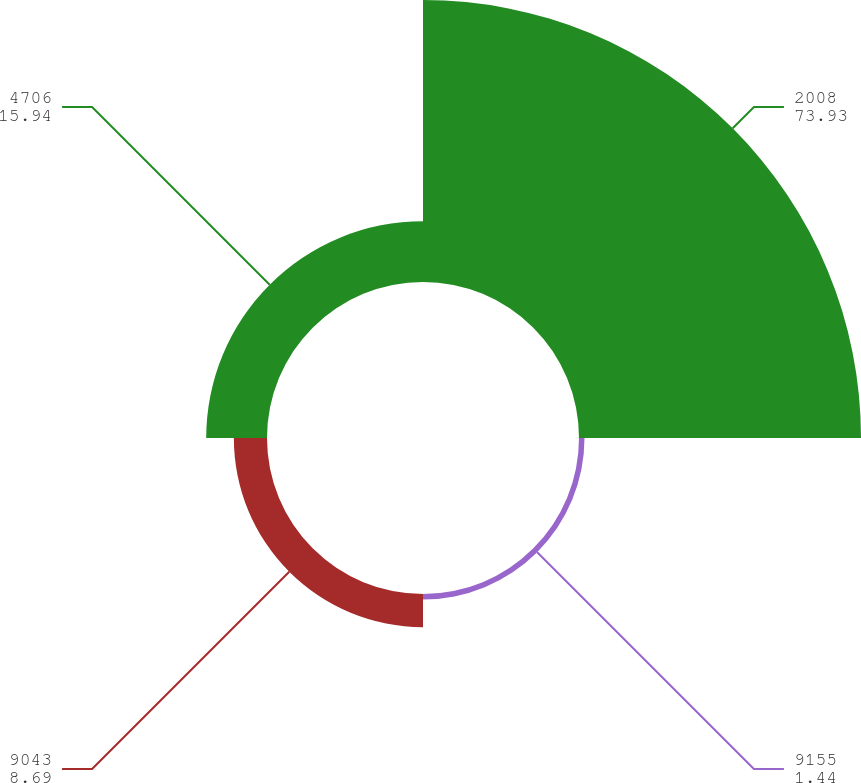Convert chart to OTSL. <chart><loc_0><loc_0><loc_500><loc_500><pie_chart><fcel>2008<fcel>9155<fcel>9043<fcel>4706<nl><fcel>73.93%<fcel>1.44%<fcel>8.69%<fcel>15.94%<nl></chart> 